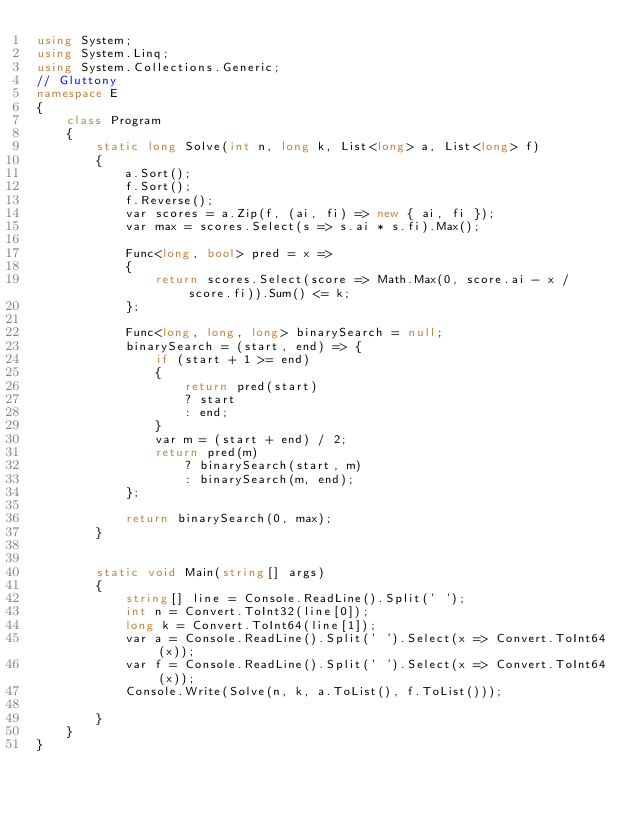<code> <loc_0><loc_0><loc_500><loc_500><_C#_>using System;
using System.Linq;
using System.Collections.Generic;
// Gluttony
namespace E
{
    class Program
    {
        static long Solve(int n, long k, List<long> a, List<long> f)
        {
            a.Sort();
            f.Sort();
            f.Reverse();
            var scores = a.Zip(f, (ai, fi) => new { ai, fi });
            var max = scores.Select(s => s.ai * s.fi).Max();

            Func<long, bool> pred = x =>
            {
                return scores.Select(score => Math.Max(0, score.ai - x / score.fi)).Sum() <= k;
            };

            Func<long, long, long> binarySearch = null;
            binarySearch = (start, end) => {
                if (start + 1 >= end)
                {
                    return pred(start)
                    ? start
                    : end;
                }
                var m = (start + end) / 2;
                return pred(m)
                    ? binarySearch(start, m)
                    : binarySearch(m, end);
            };

            return binarySearch(0, max);
        }


        static void Main(string[] args)
        {
            string[] line = Console.ReadLine().Split(' ');
            int n = Convert.ToInt32(line[0]);
            long k = Convert.ToInt64(line[1]);
            var a = Console.ReadLine().Split(' ').Select(x => Convert.ToInt64(x));
            var f = Console.ReadLine().Split(' ').Select(x => Convert.ToInt64(x));
            Console.Write(Solve(n, k, a.ToList(), f.ToList()));

        }
    }
}
</code> 